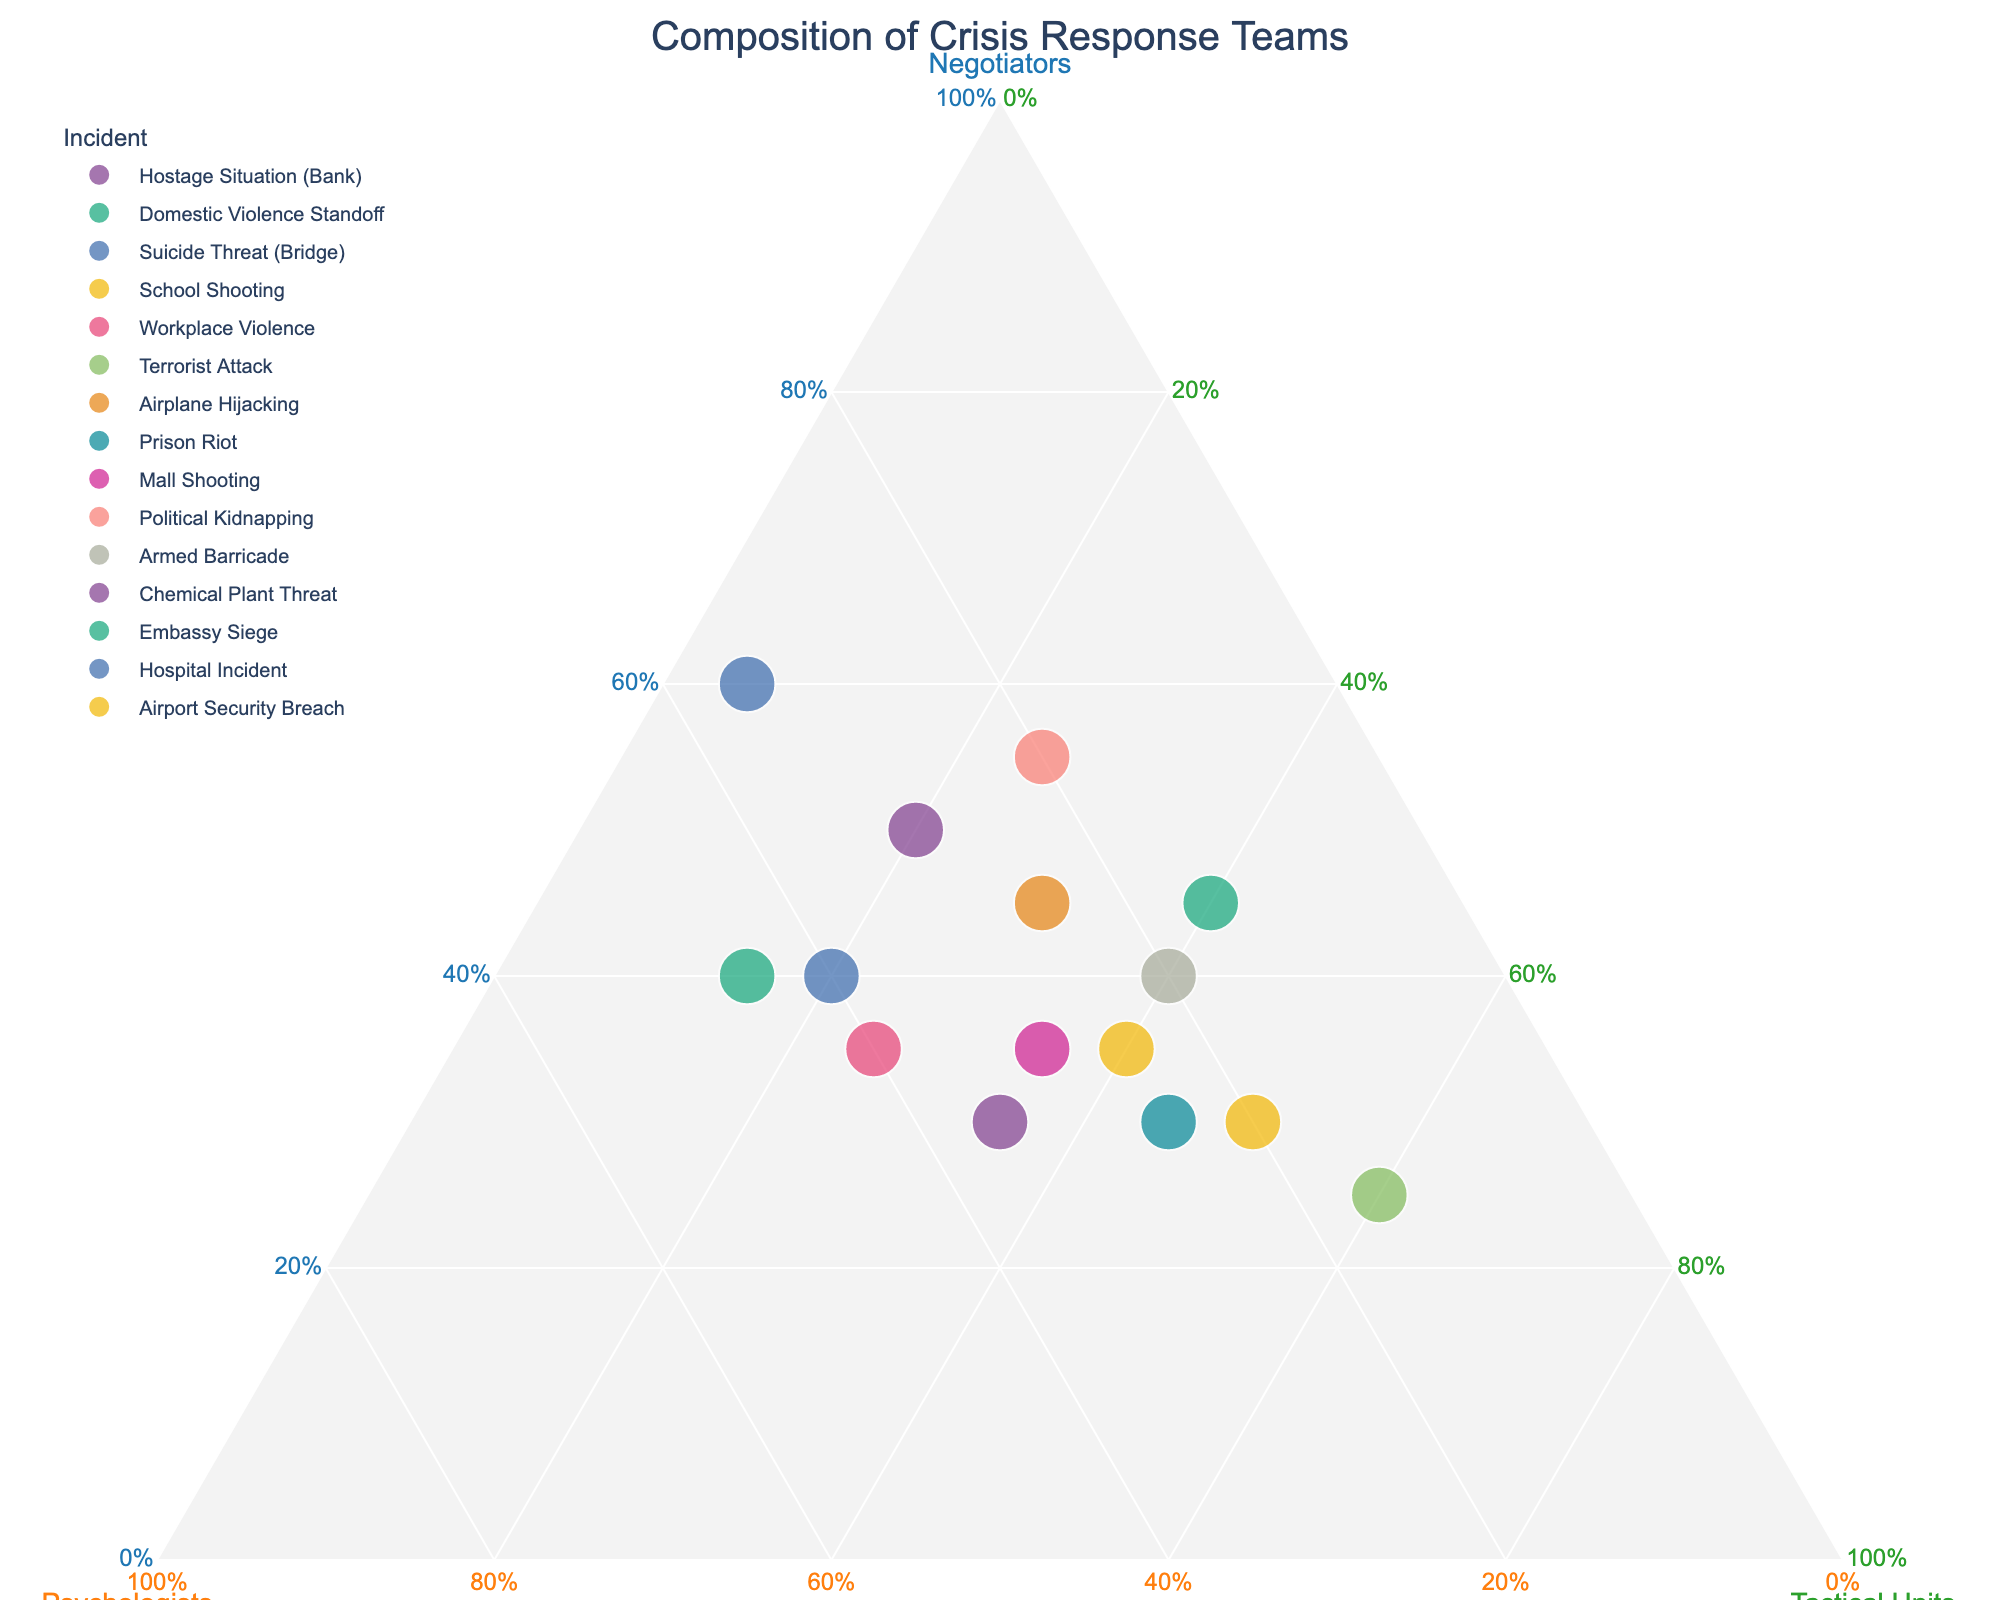What is the title of the figure? The title of the figure is typically displayed at the top.
Answer: Composition of Crisis Response Teams Which axis represents the proportion of Negotiators? In a ternary plot, each axis is labeled to represent a different component. The axis labeled 'Negotiators' represents the proportion of negotiators.
Answer: The axis on the left Which incident has the highest proportion of Tactical Units? The data points can be identified by their labels and their position relative to each axis. The point furthest along the Tactical Units axis indicates the highest proportion.
Answer: Terrorist Attack Which incident involves the highest proportion of Psychologists? Check the data point positioned closest to the Psychologists axis.
Answer: Domestic Violence Standoff What are the roles included in the crisis response teams according to the figure? The figure labels each axis with a role, making it clear which roles are included.
Answer: Negotiators, Psychologists, Tactical Units Does the incident "Hostage Situation (Bank)" have a higher proportion of Negotiators or Psychologists? Locate the “Hostage Situation (Bank)” data point and compare its positions along the Negotiator and Psychologist axes.
Answer: Higher proportion of Negotiators Which incident involves an equal proportion of Negotiators and Tactical Units? Check for a data point equidistant from both Negotiator and Tactical Units axes.
Answer: Mall Shooting How does the proportion of Psychologists in "Workplace Violence" compare to that in "Chemical Plant Threat"? Compare the positions of the data points for "Workplace Violence" and "Chemical Plant Threat" along the Psychologists axis.
Answer: Workplace Violence has a higher proportion of Psychologists Which incident has the lowest proportion of Negotiators? Identify the data point closest to the “Tactical Units” and “Psychologists” axis, which would have the smallest proportion along the Negotiator axis.
Answer: Terrorist Attack What is the unique characteristic of the ternary plot displayed? The plot facilitates the comparison of three components simultaneously, representing parts of the whole.
Answer: It represents proportions of Negotiators, Psychologists, and Tactical Units simultaneously 